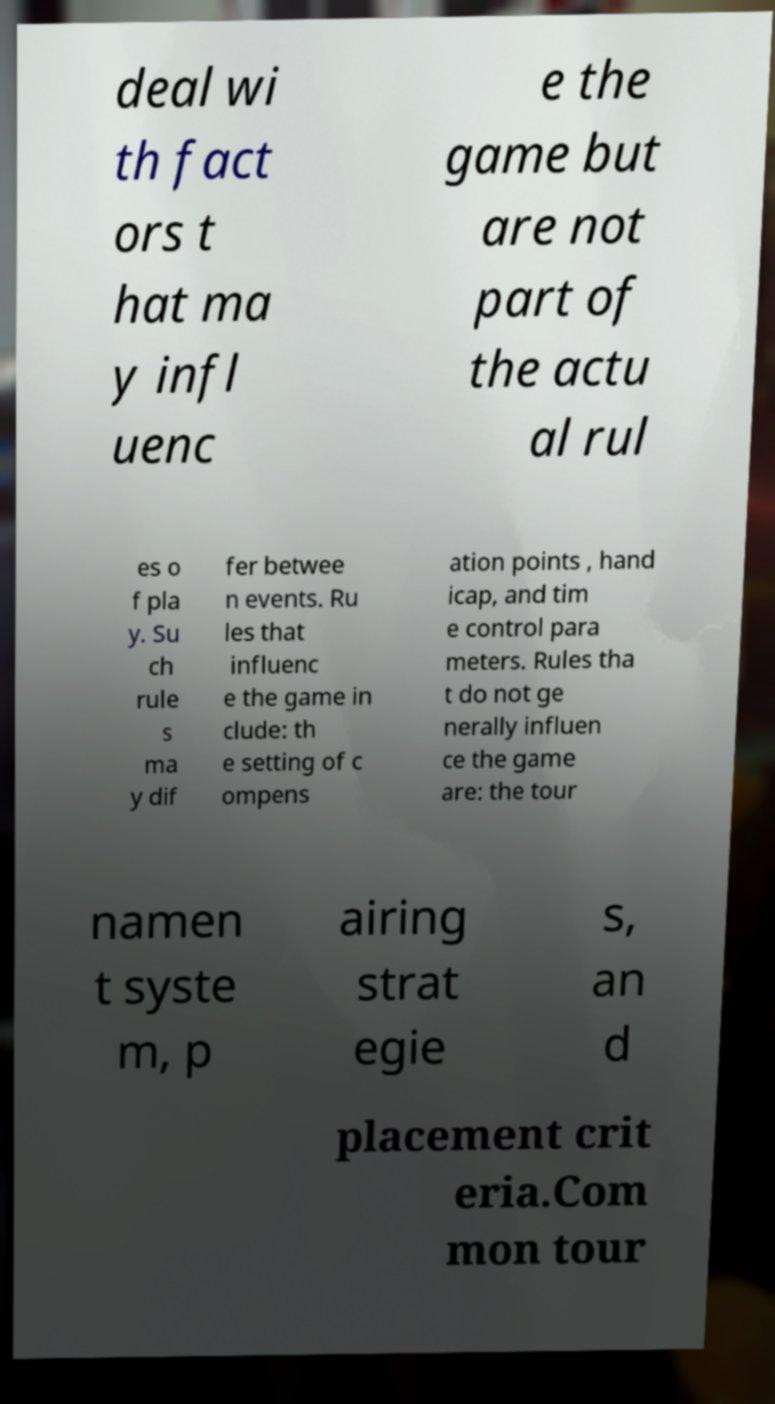Please read and relay the text visible in this image. What does it say? deal wi th fact ors t hat ma y infl uenc e the game but are not part of the actu al rul es o f pla y. Su ch rule s ma y dif fer betwee n events. Ru les that influenc e the game in clude: th e setting of c ompens ation points , hand icap, and tim e control para meters. Rules tha t do not ge nerally influen ce the game are: the tour namen t syste m, p airing strat egie s, an d placement crit eria.Com mon tour 